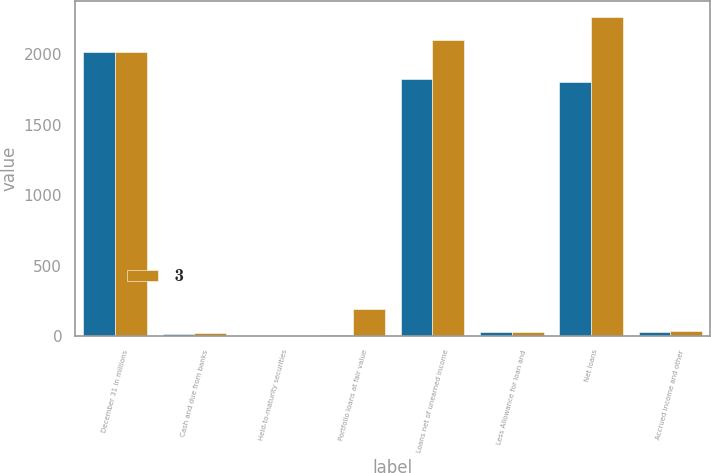<chart> <loc_0><loc_0><loc_500><loc_500><stacked_bar_chart><ecel><fcel>December 31 in millions<fcel>Cash and due from banks<fcel>Held-to-maturity securities<fcel>Portfolio loans at fair value<fcel>Loans net of unearned income<fcel>Less Allowance for loan and<fcel>Net loans<fcel>Accrued income and other<nl><fcel>nan<fcel>2015<fcel>15<fcel>1<fcel>4<fcel>1824<fcel>28<fcel>1800<fcel>30<nl><fcel>3<fcel>2014<fcel>19<fcel>1<fcel>191<fcel>2104<fcel>29<fcel>2266<fcel>38<nl></chart> 